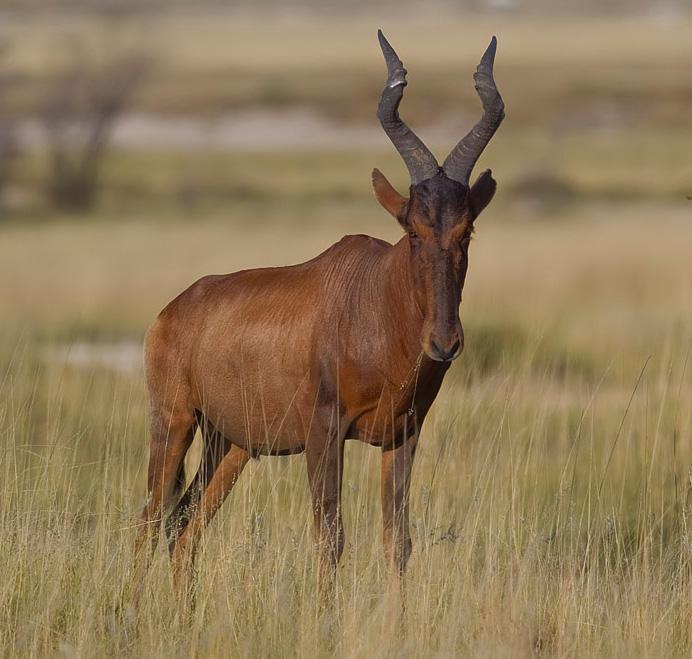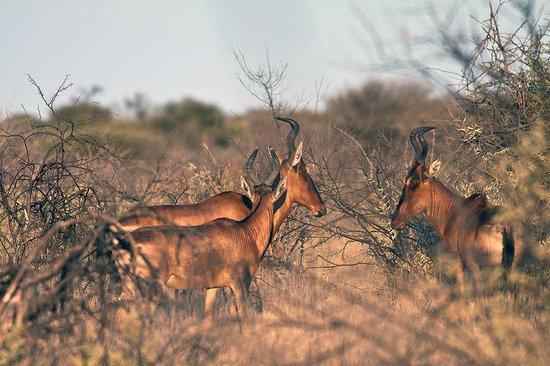The first image is the image on the left, the second image is the image on the right. Evaluate the accuracy of this statement regarding the images: "There are four ruminant animals (antelope types).". Is it true? Answer yes or no. Yes. The first image is the image on the left, the second image is the image on the right. For the images shown, is this caption "Left image contains one horned animal, which is eyeing the camera, with its body turned rightward." true? Answer yes or no. Yes. 